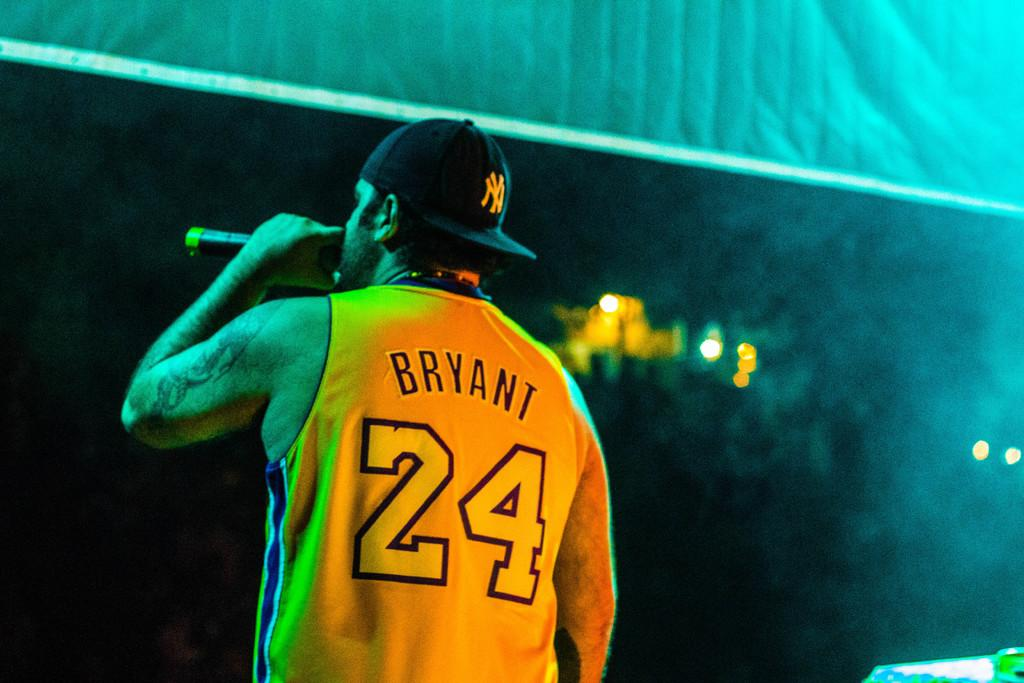<image>
Provide a brief description of the given image. A man wearing a Bryant number 24 jersey and a baseball cap is singing on a stage. 